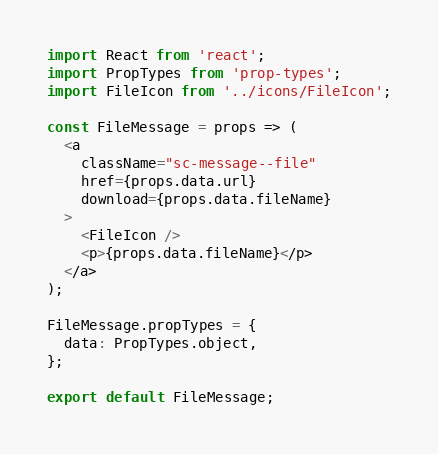Convert code to text. <code><loc_0><loc_0><loc_500><loc_500><_JavaScript_>import React from 'react';
import PropTypes from 'prop-types';
import FileIcon from '../icons/FileIcon';

const FileMessage = props => (
  <a
    className="sc-message--file"
    href={props.data.url}
    download={props.data.fileName}
  >
    <FileIcon />
    <p>{props.data.fileName}</p>
  </a>
);

FileMessage.propTypes = {
  data: PropTypes.object,
};

export default FileMessage;
</code> 